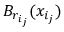<formula> <loc_0><loc_0><loc_500><loc_500>B _ { r _ { i _ { j } } } ( x _ { i _ { j } } )</formula> 